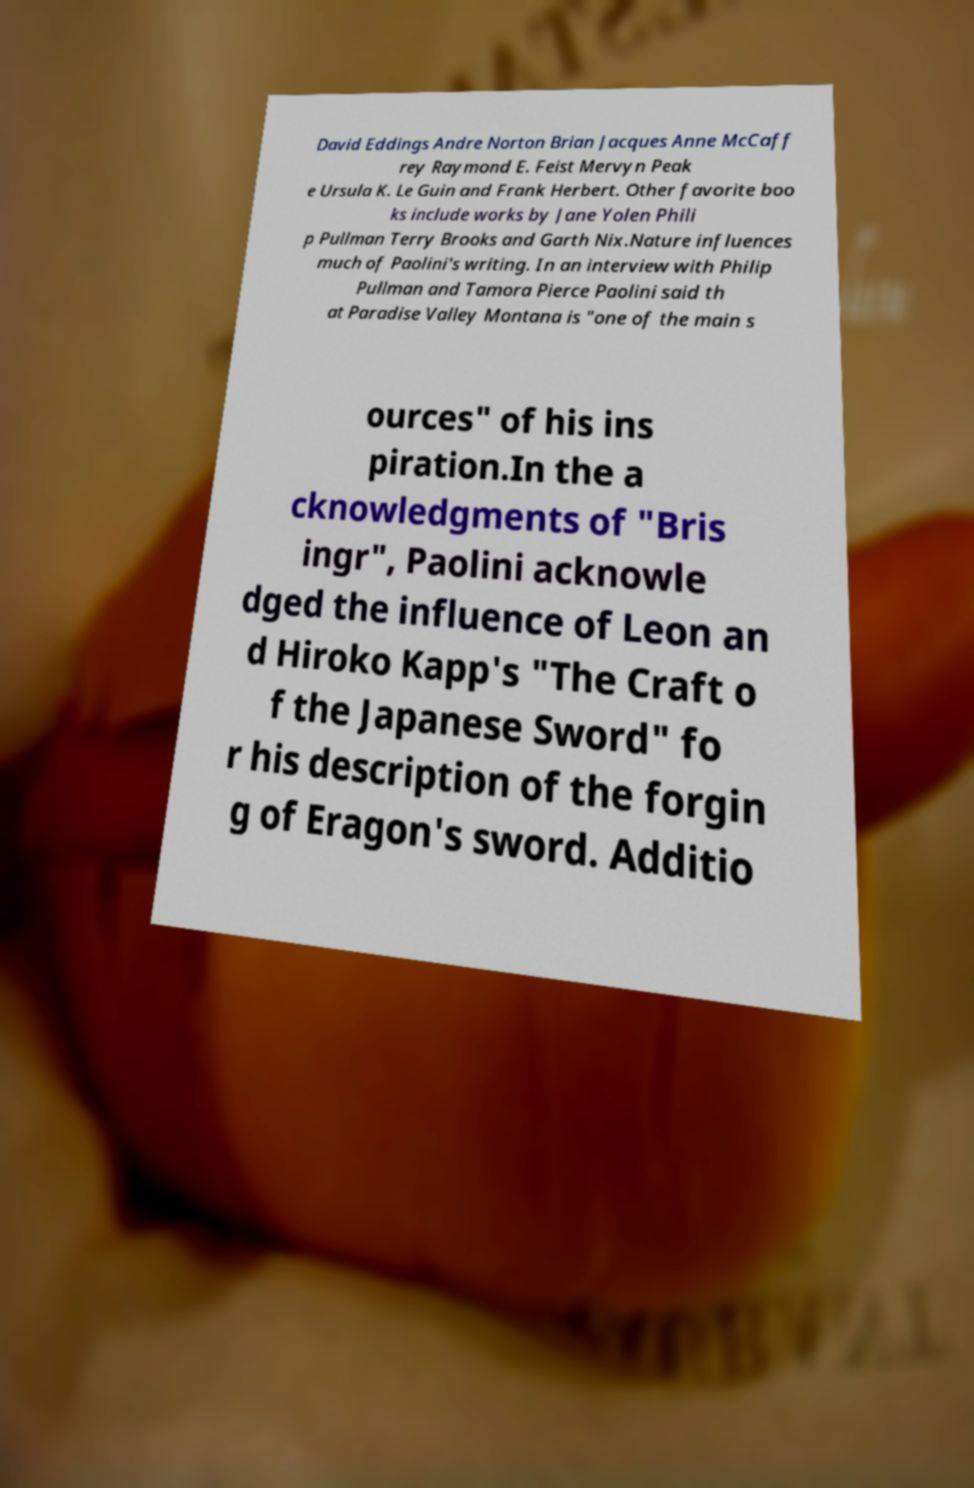What messages or text are displayed in this image? I need them in a readable, typed format. David Eddings Andre Norton Brian Jacques Anne McCaff rey Raymond E. Feist Mervyn Peak e Ursula K. Le Guin and Frank Herbert. Other favorite boo ks include works by Jane Yolen Phili p Pullman Terry Brooks and Garth Nix.Nature influences much of Paolini's writing. In an interview with Philip Pullman and Tamora Pierce Paolini said th at Paradise Valley Montana is "one of the main s ources" of his ins piration.In the a cknowledgments of "Bris ingr", Paolini acknowle dged the influence of Leon an d Hiroko Kapp's "The Craft o f the Japanese Sword" fo r his description of the forgin g of Eragon's sword. Additio 